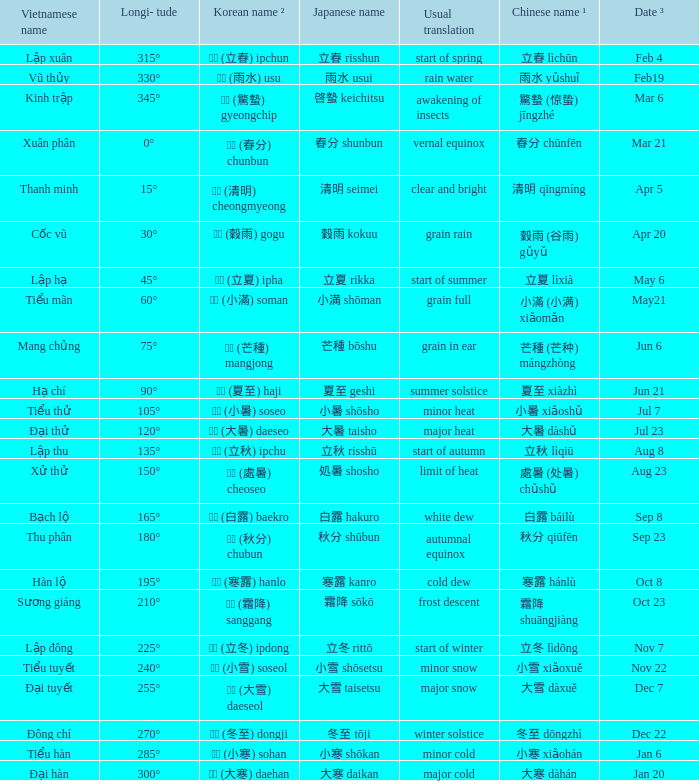WHich Usual translation is on sep 23? Autumnal equinox. 